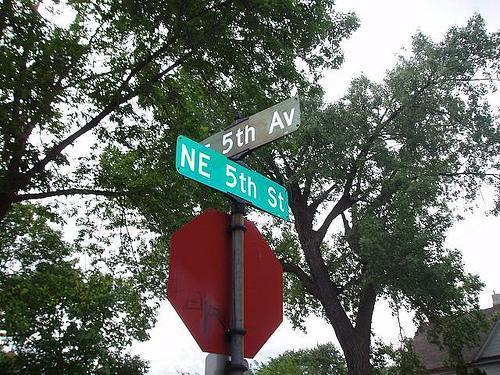How many houses are pictured?
Give a very brief answer. 1. How many red signs are posted?
Give a very brief answer. 1. 